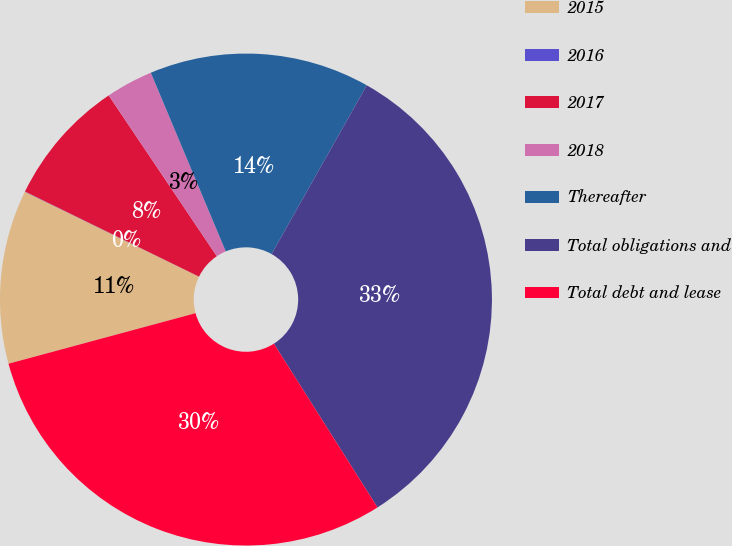Convert chart to OTSL. <chart><loc_0><loc_0><loc_500><loc_500><pie_chart><fcel>2015<fcel>2016<fcel>2017<fcel>2018<fcel>Thereafter<fcel>Total obligations and<fcel>Total debt and lease<nl><fcel>11.42%<fcel>0.02%<fcel>8.34%<fcel>3.1%<fcel>14.49%<fcel>32.85%<fcel>29.78%<nl></chart> 